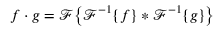<formula> <loc_0><loc_0><loc_500><loc_500>f \cdot g = { \mathcal { F } } { \left \{ } { \mathcal { F } } ^ { - 1 } \{ f \} * { \mathcal { F } } ^ { - 1 } \{ g \} { \right \} }</formula> 